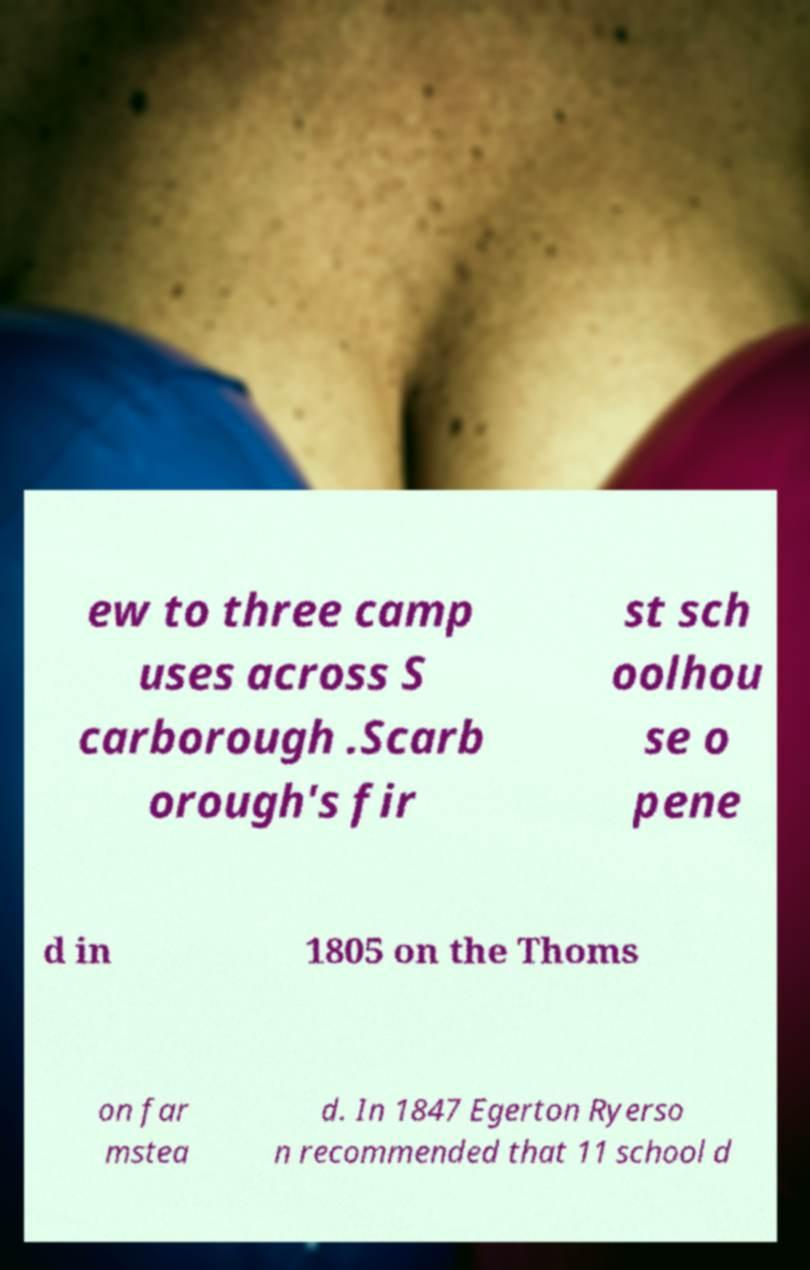I need the written content from this picture converted into text. Can you do that? ew to three camp uses across S carborough .Scarb orough's fir st sch oolhou se o pene d in 1805 on the Thoms on far mstea d. In 1847 Egerton Ryerso n recommended that 11 school d 